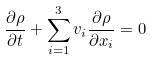<formula> <loc_0><loc_0><loc_500><loc_500>\frac { \partial \rho } { \partial t } + \sum _ { i = 1 } ^ { 3 } v _ { i } \frac { \partial \rho } { \partial x _ { i } } = 0</formula> 